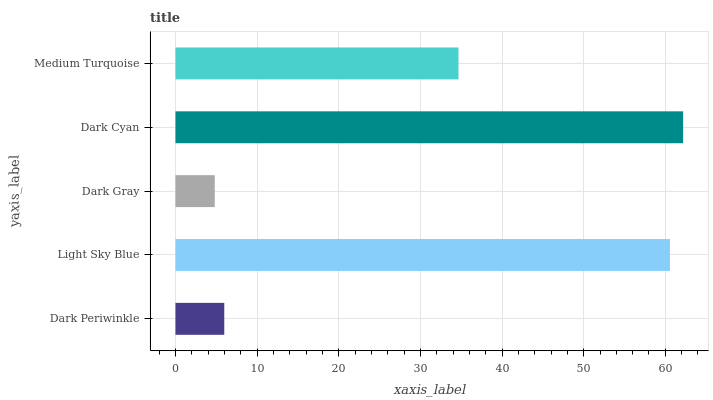Is Dark Gray the minimum?
Answer yes or no. Yes. Is Dark Cyan the maximum?
Answer yes or no. Yes. Is Light Sky Blue the minimum?
Answer yes or no. No. Is Light Sky Blue the maximum?
Answer yes or no. No. Is Light Sky Blue greater than Dark Periwinkle?
Answer yes or no. Yes. Is Dark Periwinkle less than Light Sky Blue?
Answer yes or no. Yes. Is Dark Periwinkle greater than Light Sky Blue?
Answer yes or no. No. Is Light Sky Blue less than Dark Periwinkle?
Answer yes or no. No. Is Medium Turquoise the high median?
Answer yes or no. Yes. Is Medium Turquoise the low median?
Answer yes or no. Yes. Is Dark Cyan the high median?
Answer yes or no. No. Is Dark Periwinkle the low median?
Answer yes or no. No. 